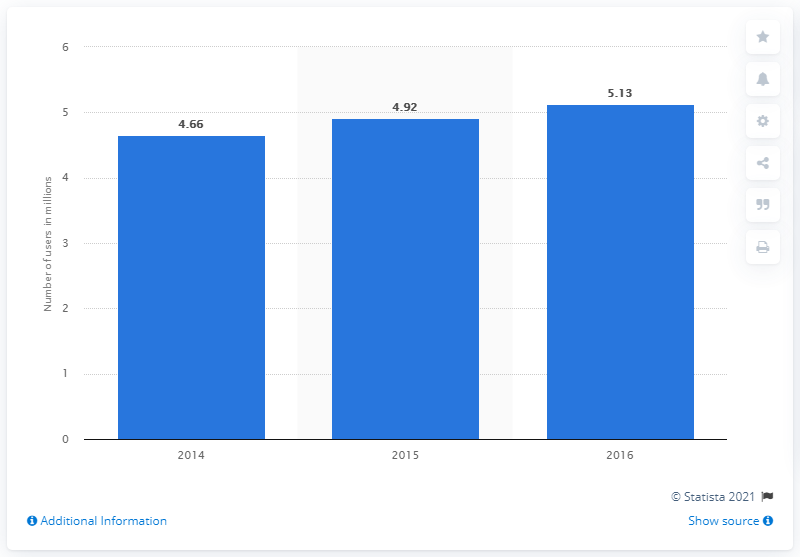Point out several critical features in this image. The average number of Twitter users in South Korea between 2014 and 2016 was approximately 4.9 million. In 2016, the number of Twitter users in South Korea was the greatest among all years. In 2015, there were approximately 4.92 million Twitter users in South Korea. 